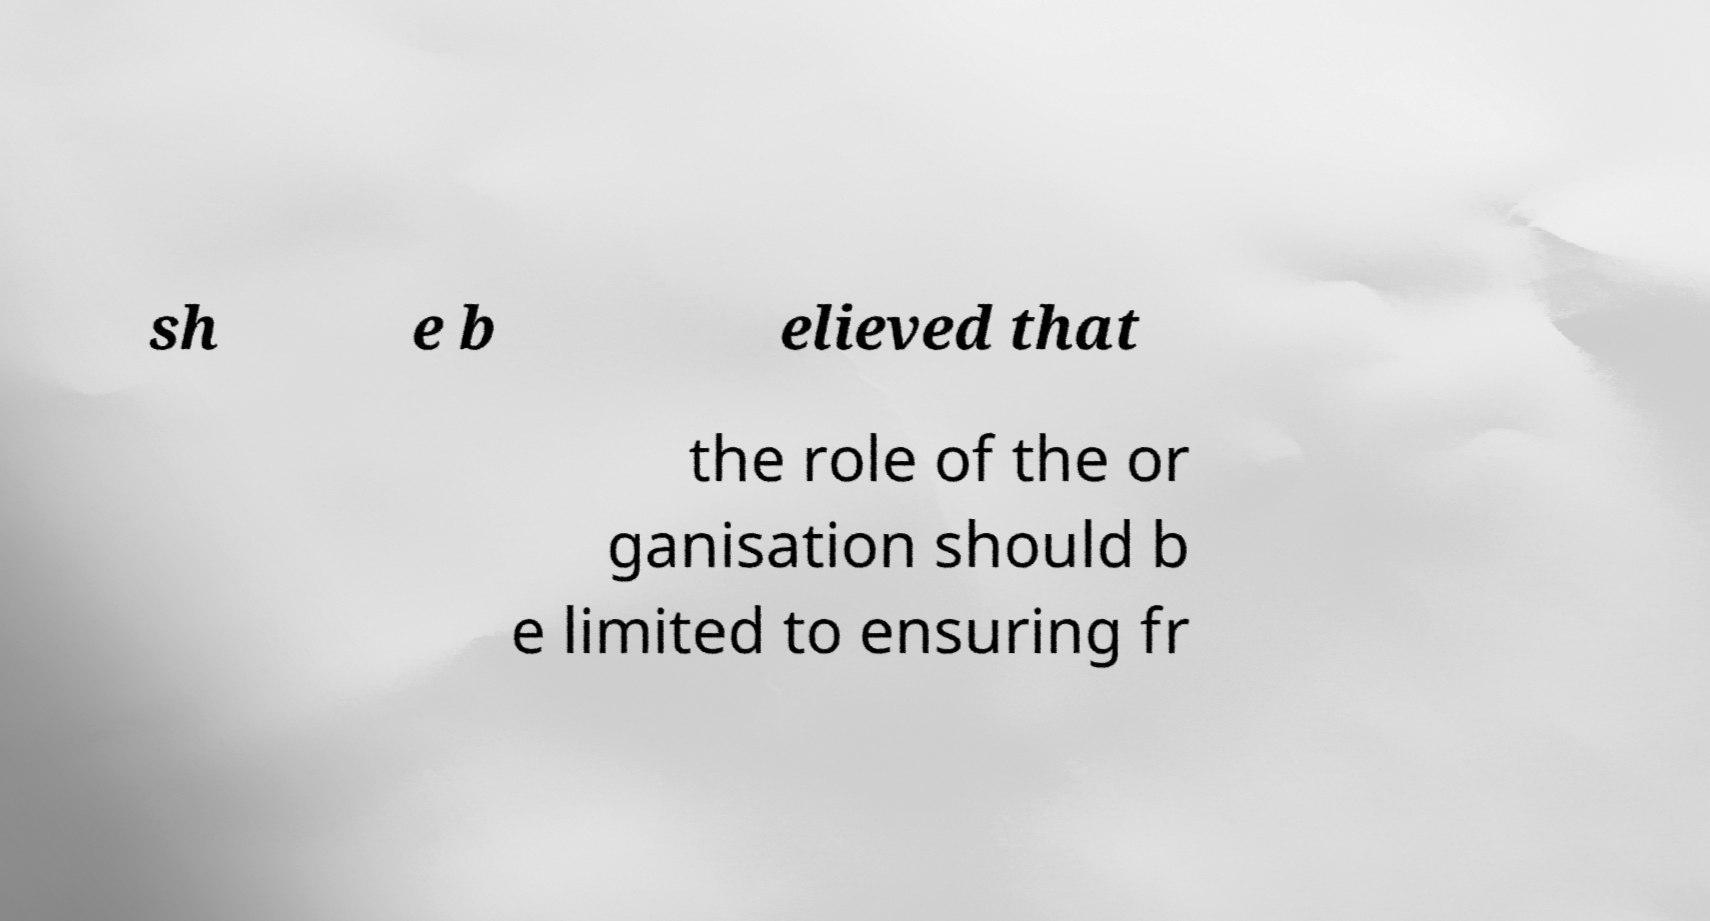For documentation purposes, I need the text within this image transcribed. Could you provide that? sh e b elieved that the role of the or ganisation should b e limited to ensuring fr 